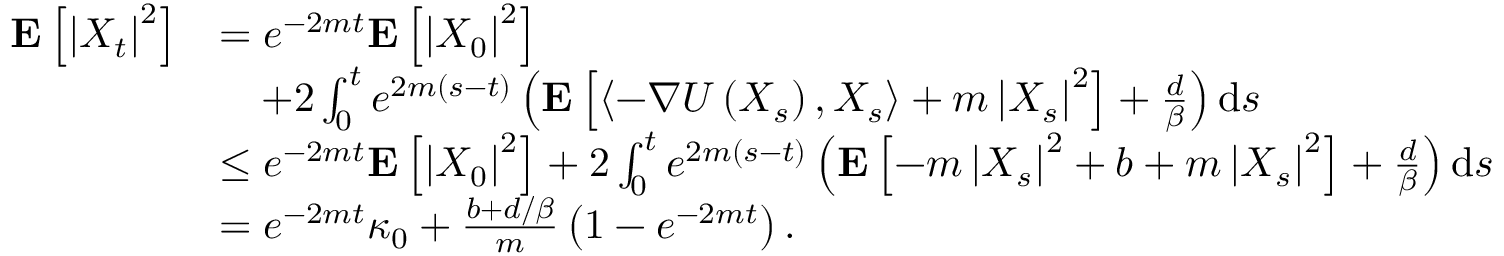Convert formula to latex. <formula><loc_0><loc_0><loc_500><loc_500>\begin{array} { r l } { E \left [ \left | X _ { t } \right | ^ { 2 } \right ] } & { = e ^ { - 2 m t } E \left [ \left | X _ { 0 } \right | ^ { 2 } \right ] } \\ & { \quad + 2 \int _ { 0 } ^ { t } e ^ { 2 m ( s - t ) } \left ( E \left [ \left \langle - \nabla U \left ( X _ { s } \right ) , X _ { s } \right \rangle + m \left | X _ { s } \right | ^ { 2 } \right ] + \frac { d } { \beta } \right ) d s } \\ & { \leq e ^ { - 2 m t } E \left [ \left | X _ { 0 } \right | ^ { 2 } \right ] + 2 \int _ { 0 } ^ { t } e ^ { 2 m ( s - t ) } \left ( E \left [ - m \left | X _ { s } \right | ^ { 2 } + b + m \left | X _ { s } \right | ^ { 2 } \right ] + \frac { d } { \beta } \right ) d s } \\ & { = e ^ { - 2 m t } \kappa _ { 0 } + \frac { b + d / \beta } { m } \left ( 1 - e ^ { - 2 m t } \right ) . } \end{array}</formula> 